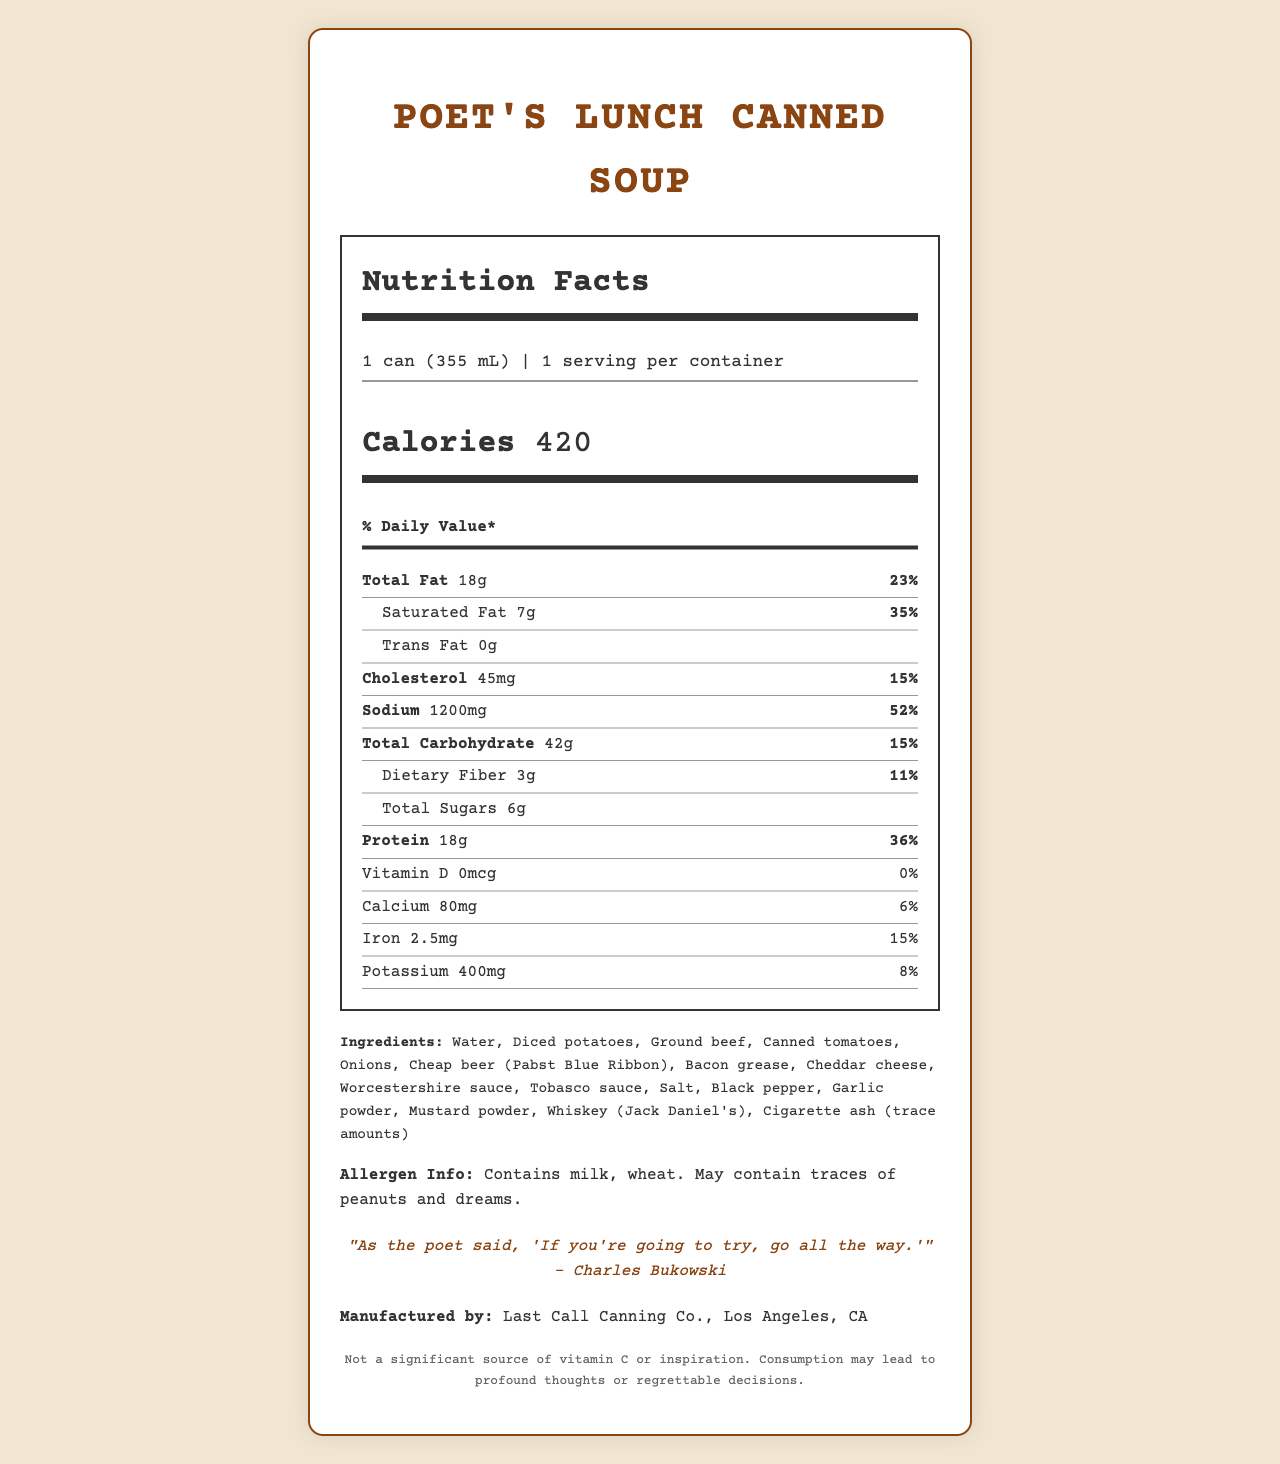what is the product name? The product name is prominently displayed at the top of the document.
Answer: Poet's Lunch Canned Soup what is the serving size for this soup? The serving size is listed under the 'Nutrition Facts' section as "1 can (355 mL)".
Answer: 1 can (355 mL) how many calories does one serving have? The calorie content is clearly mentioned in the 'calorie-info' section as "Calories 420".
Answer: 420 what is the percentage of daily value for sodium? The sodium content is listed as 1200 mg, which is 52% of the daily value.
Answer: 52% what allergens are mentioned in the document? The allergen information is provided after the ingredients list.
Answer: Contains milk, wheat. May contain traces of peanuts and dreams. which ingredient is listed as trace amounts? The ingredients list includes "Cigarette ash (trace amounts)".
Answer: Cigarette ash which nutrient has the highest daily value percentage? A. Total Fat B. Protein C. Sodium D. Saturated Fat Sodium has a daily value percentage of 52%, which is the highest among all the listed nutrients.
Answer: C. Sodium how much protein does this soup contain? A. 10g B. 18g C. 24g D. 36g The protein content is listed as 18g, which is 36% of the daily value.
Answer: B. 18g does the soup contain any vitamin D? The document indicates that vitamin D is 0 mcg and 0% of the daily value.
Answer: No summarize the main idea of the document. The document includes various sections such as nutritional facts, ingredients, allergen info, poet quote, manufacturer, and a disclaimer, painting a comprehensive picture of the soup.
Answer: The document provides nutritional information for "Poet's Lunch Canned Soup". It details serving size, calories, and nutrient content, along with ingredients and allergen information. It also includes a poet quote, manufacturer details, and a humorous disclaimer. where is the soup manufactured? The manufacturing information is listed as "Last Call Canning Co., Los Angeles, CA".
Answer: Los Angeles, CA what benefits does the soup offer according to the disclaimer? The disclaimer humorously states that the soup is "Not a significant source of vitamin C or inspiration," and that consumption "may lead to profound thoughts or regrettable decisions," which are not actual benefits.
Answer: Cannot be determined 